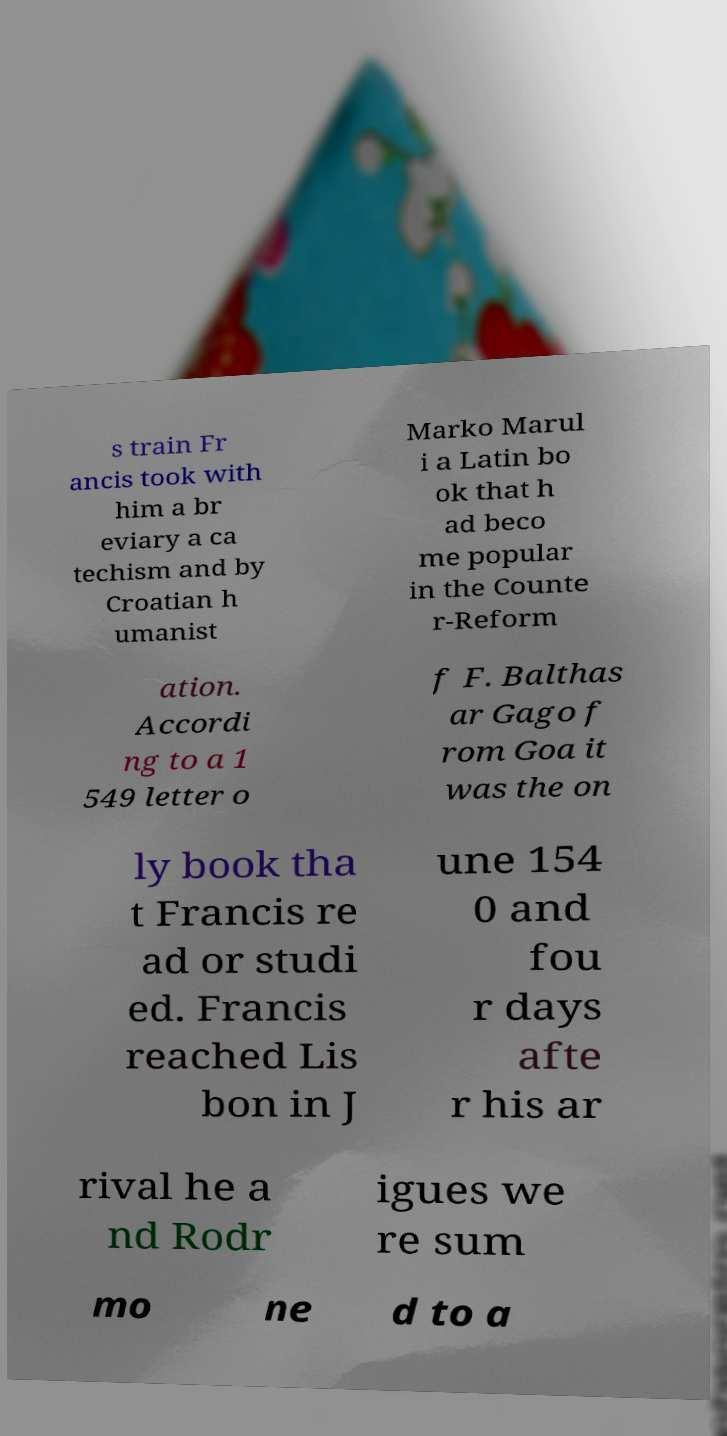I need the written content from this picture converted into text. Can you do that? s train Fr ancis took with him a br eviary a ca techism and by Croatian h umanist Marko Marul i a Latin bo ok that h ad beco me popular in the Counte r-Reform ation. Accordi ng to a 1 549 letter o f F. Balthas ar Gago f rom Goa it was the on ly book tha t Francis re ad or studi ed. Francis reached Lis bon in J une 154 0 and fou r days afte r his ar rival he a nd Rodr igues we re sum mo ne d to a 